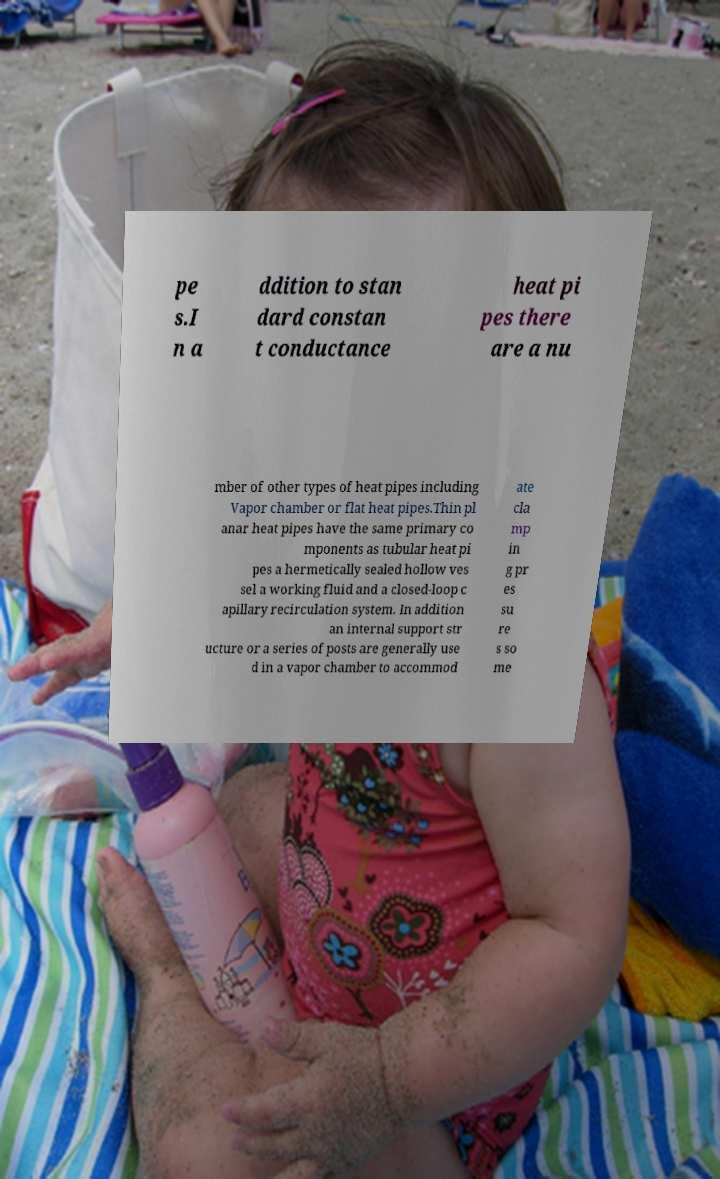Please read and relay the text visible in this image. What does it say? pe s.I n a ddition to stan dard constan t conductance heat pi pes there are a nu mber of other types of heat pipes including Vapor chamber or flat heat pipes.Thin pl anar heat pipes have the same primary co mponents as tubular heat pi pes a hermetically sealed hollow ves sel a working fluid and a closed-loop c apillary recirculation system. In addition an internal support str ucture or a series of posts are generally use d in a vapor chamber to accommod ate cla mp in g pr es su re s so me 